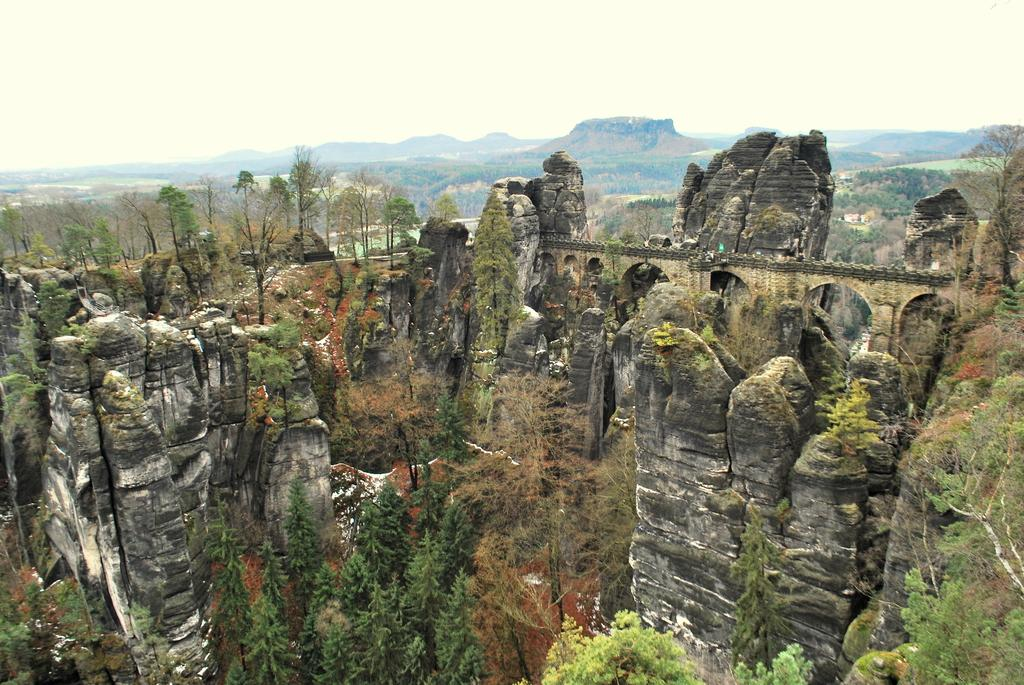What type of view is provided in the image? The image is a top view. What natural elements can be seen in the image? There are rocks, trees, and hills visible in the image. What man-made structure is present in the image? There is a bridge in the image. What is visible in the background of the image? The sky is visible in the background of the image. How many pins are attached to the trees in the image? There are no pins present in the image; it features rocks, trees, hills, a bridge, and the sky. What color is the cloud in the image? There are no clouds visible in the image; only the sky is present in the background. 